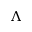Convert formula to latex. <formula><loc_0><loc_0><loc_500><loc_500>\Lambda</formula> 